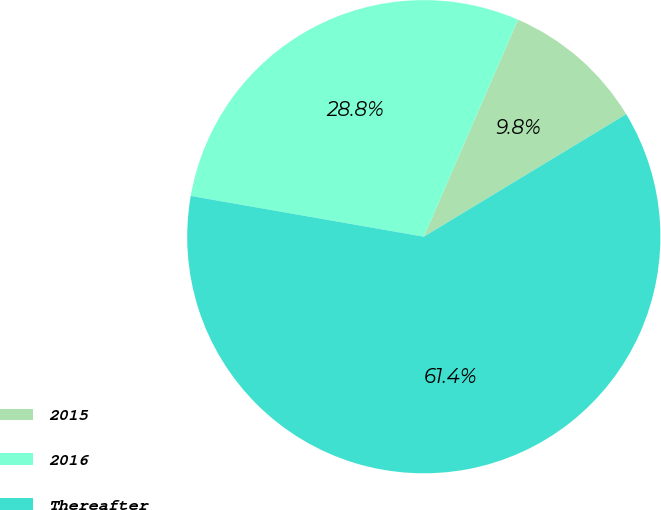Convert chart to OTSL. <chart><loc_0><loc_0><loc_500><loc_500><pie_chart><fcel>2015<fcel>2016<fcel>Thereafter<nl><fcel>9.82%<fcel>28.76%<fcel>61.42%<nl></chart> 